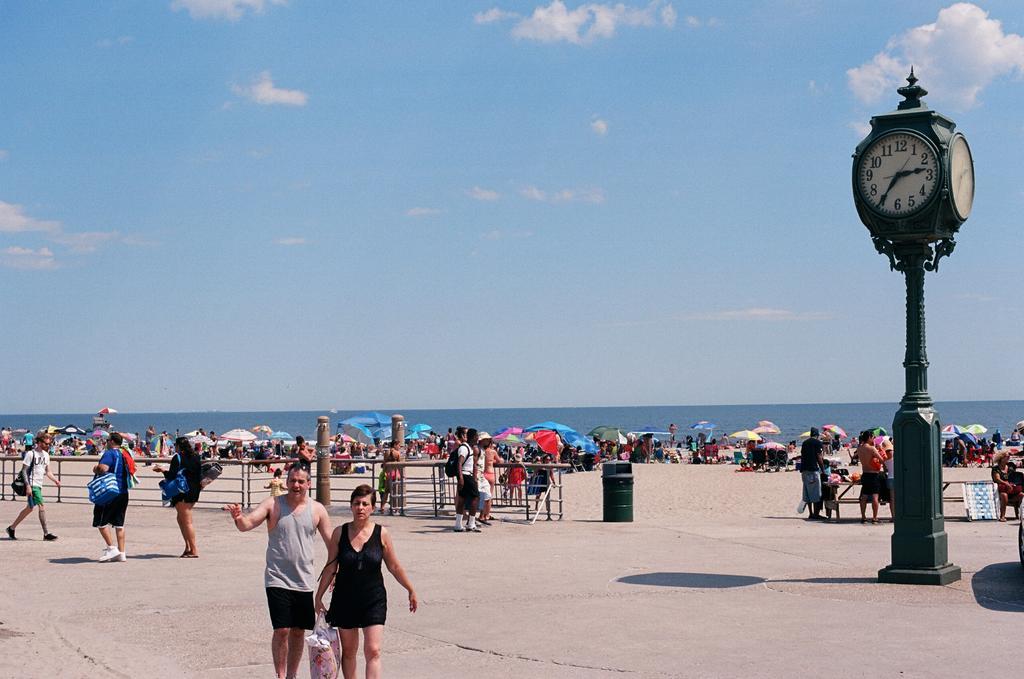In one or two sentences, can you explain what this image depicts? As we can see in the image there is fence, dustbin, group of people, bench, umbrellas, clock and water. At the top there is sky and clouds. 